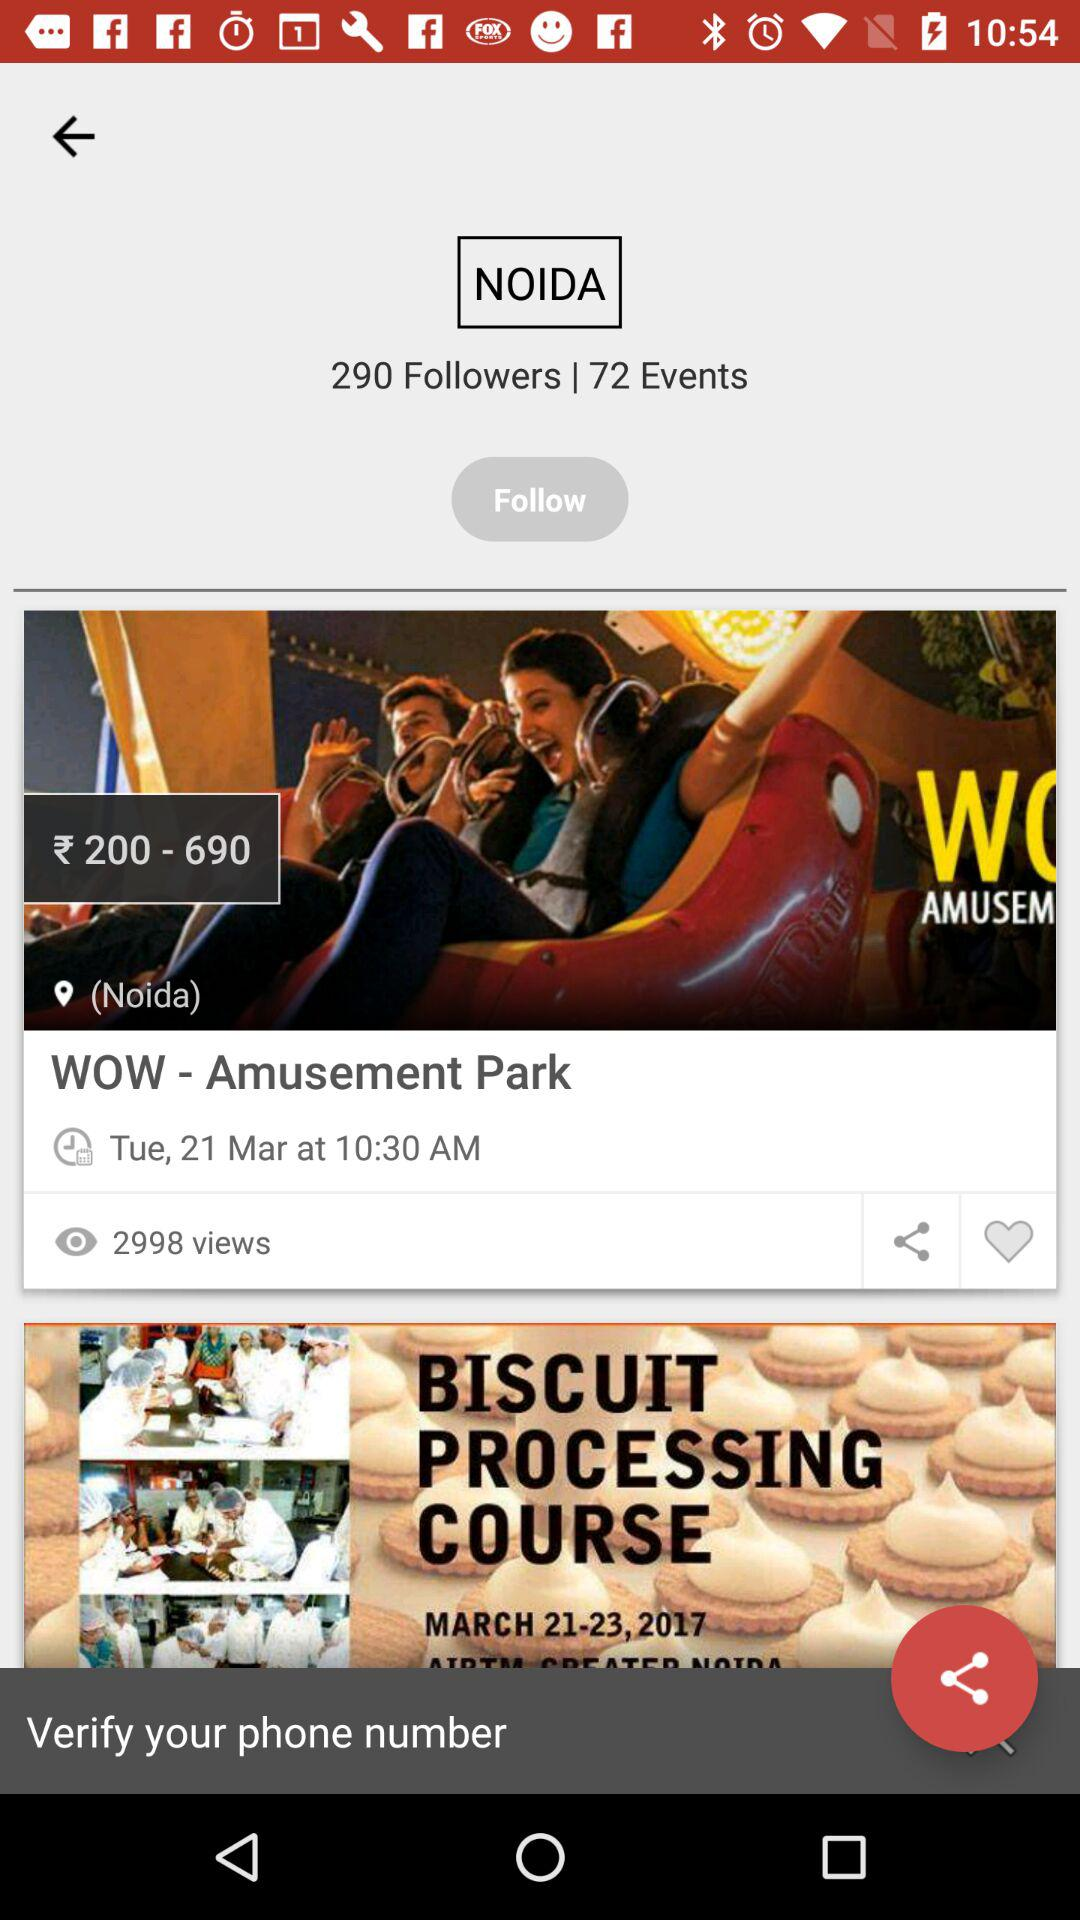For which date is the "BISCUIT PROCESSING COURSE" scheduled? The "BISCUIT PROCESSING COURSE" is scheduled from March 21 to March 23, 2017. 